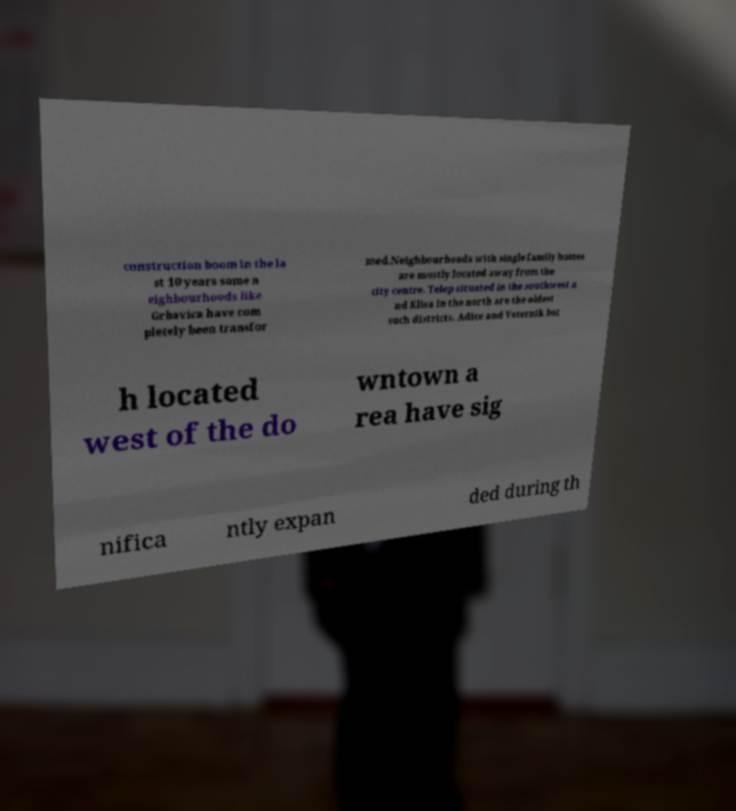For documentation purposes, I need the text within this image transcribed. Could you provide that? construction boom in the la st 10 years some n eighbourhoods like Grbavica have com pletely been transfor med.Neighbourhoods with single family homes are mostly located away from the city centre. Telep situated in the southwest a nd Klisa in the north are the oldest such districts. Adice and Veternik bot h located west of the do wntown a rea have sig nifica ntly expan ded during th 